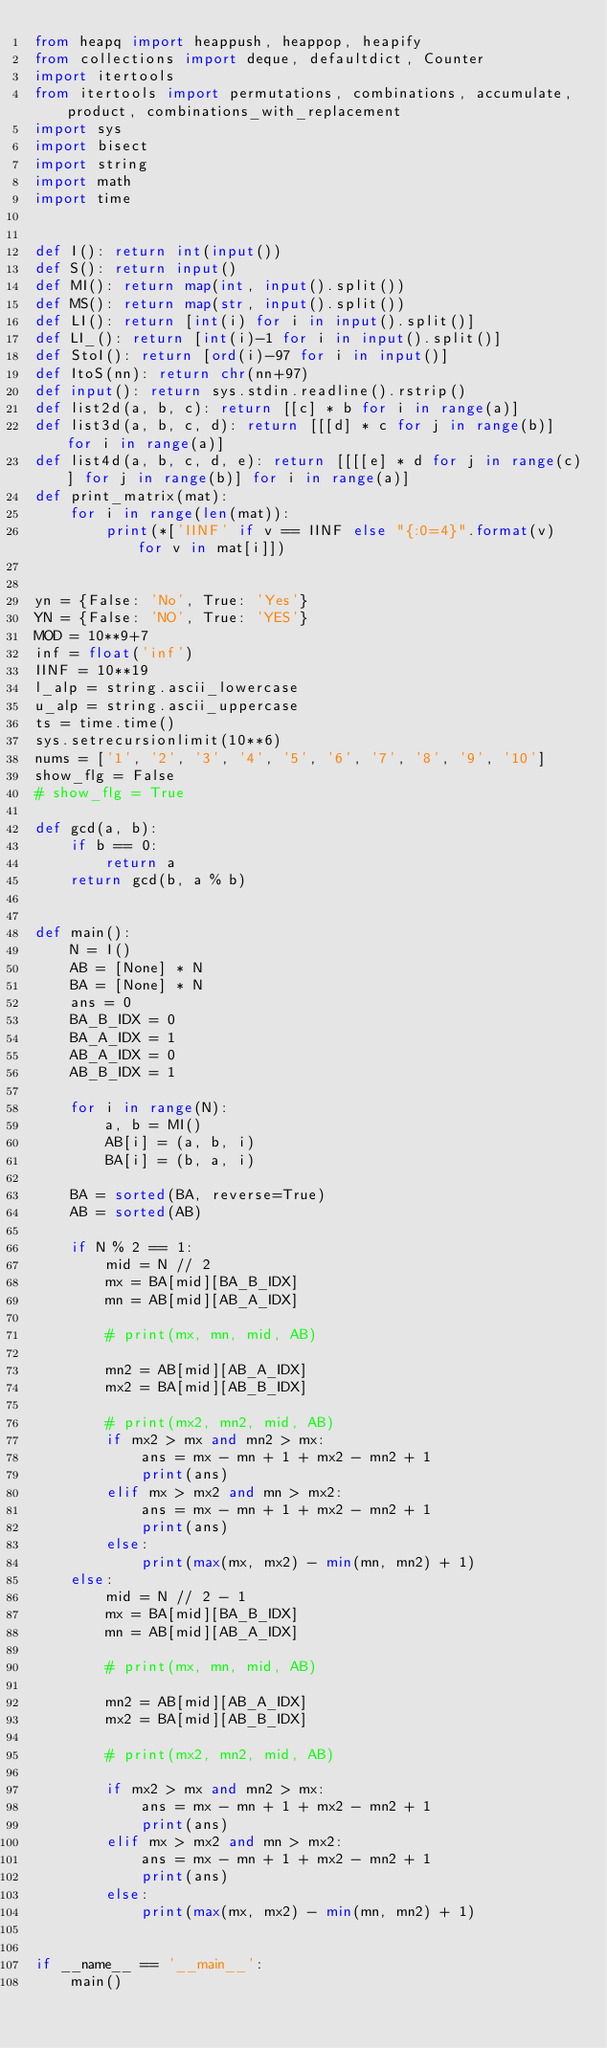<code> <loc_0><loc_0><loc_500><loc_500><_Python_>from heapq import heappush, heappop, heapify
from collections import deque, defaultdict, Counter
import itertools
from itertools import permutations, combinations, accumulate, product, combinations_with_replacement
import sys
import bisect
import string
import math
import time


def I(): return int(input())
def S(): return input()
def MI(): return map(int, input().split())
def MS(): return map(str, input().split())
def LI(): return [int(i) for i in input().split()]
def LI_(): return [int(i)-1 for i in input().split()]
def StoI(): return [ord(i)-97 for i in input()]
def ItoS(nn): return chr(nn+97)
def input(): return sys.stdin.readline().rstrip()
def list2d(a, b, c): return [[c] * b for i in range(a)]
def list3d(a, b, c, d): return [[[d] * c for j in range(b)] for i in range(a)]
def list4d(a, b, c, d, e): return [[[[e] * d for j in range(c)] for j in range(b)] for i in range(a)]
def print_matrix(mat):
    for i in range(len(mat)):
        print(*['IINF' if v == IINF else "{:0=4}".format(v) for v in mat[i]])


yn = {False: 'No', True: 'Yes'}
YN = {False: 'NO', True: 'YES'}
MOD = 10**9+7
inf = float('inf')
IINF = 10**19
l_alp = string.ascii_lowercase
u_alp = string.ascii_uppercase
ts = time.time()
sys.setrecursionlimit(10**6)
nums = ['1', '2', '3', '4', '5', '6', '7', '8', '9', '10']
show_flg = False
# show_flg = True

def gcd(a, b):
    if b == 0:
        return a
    return gcd(b, a % b)


def main():
    N = I()
    AB = [None] * N
    BA = [None] * N
    ans = 0
    BA_B_IDX = 0
    BA_A_IDX = 1
    AB_A_IDX = 0
    AB_B_IDX = 1

    for i in range(N):
        a, b = MI()
        AB[i] = (a, b, i)
        BA[i] = (b, a, i)

    BA = sorted(BA, reverse=True)
    AB = sorted(AB)

    if N % 2 == 1:
        mid = N // 2
        mx = BA[mid][BA_B_IDX]
        mn = AB[mid][AB_A_IDX]

        # print(mx, mn, mid, AB)

        mn2 = AB[mid][AB_A_IDX]
        mx2 = BA[mid][AB_B_IDX]

        # print(mx2, mn2, mid, AB)
        if mx2 > mx and mn2 > mx:
            ans = mx - mn + 1 + mx2 - mn2 + 1
            print(ans)
        elif mx > mx2 and mn > mx2:
            ans = mx - mn + 1 + mx2 - mn2 + 1
            print(ans)
        else:
            print(max(mx, mx2) - min(mn, mn2) + 1)
    else:
        mid = N // 2 - 1
        mx = BA[mid][BA_B_IDX]
        mn = AB[mid][AB_A_IDX]

        # print(mx, mn, mid, AB)

        mn2 = AB[mid][AB_A_IDX]
        mx2 = BA[mid][AB_B_IDX]

        # print(mx2, mn2, mid, AB)

        if mx2 > mx and mn2 > mx:
            ans = mx - mn + 1 + mx2 - mn2 + 1
            print(ans)
        elif mx > mx2 and mn > mx2:
            ans = mx - mn + 1 + mx2 - mn2 + 1
            print(ans)
        else:
            print(max(mx, mx2) - min(mn, mn2) + 1)


if __name__ == '__main__':
    main()
</code> 